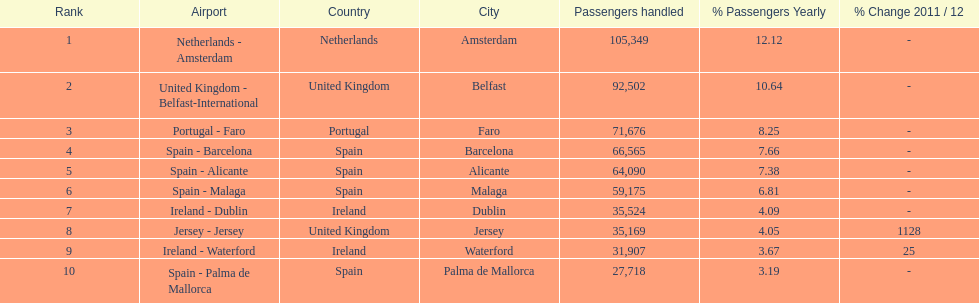Which airport has no more than 30,000 passengers handled among the 10 busiest routes to and from london southend airport in 2012? Spain - Palma de Mallorca. 